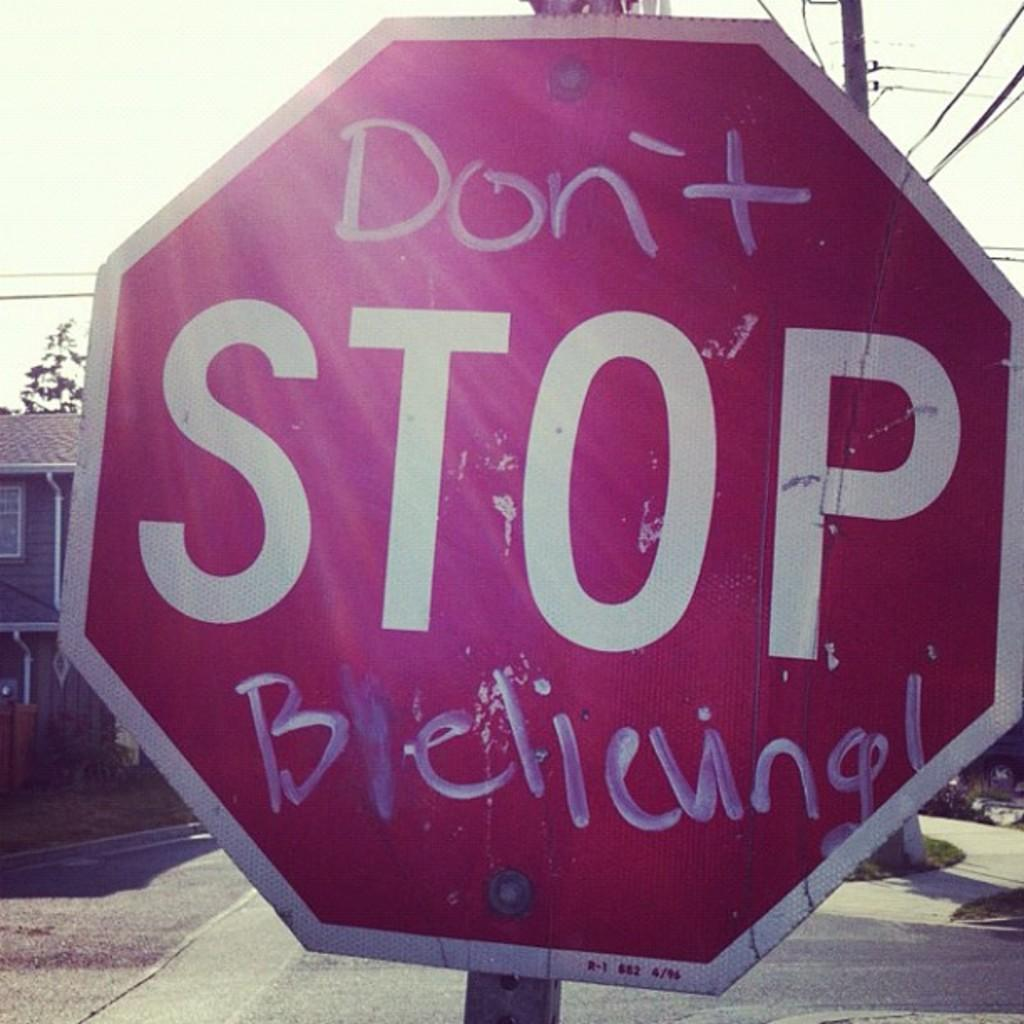<image>
Present a compact description of the photo's key features. The Stop sign has been written on by someone so it reads 'Don't Stop Believing!". 